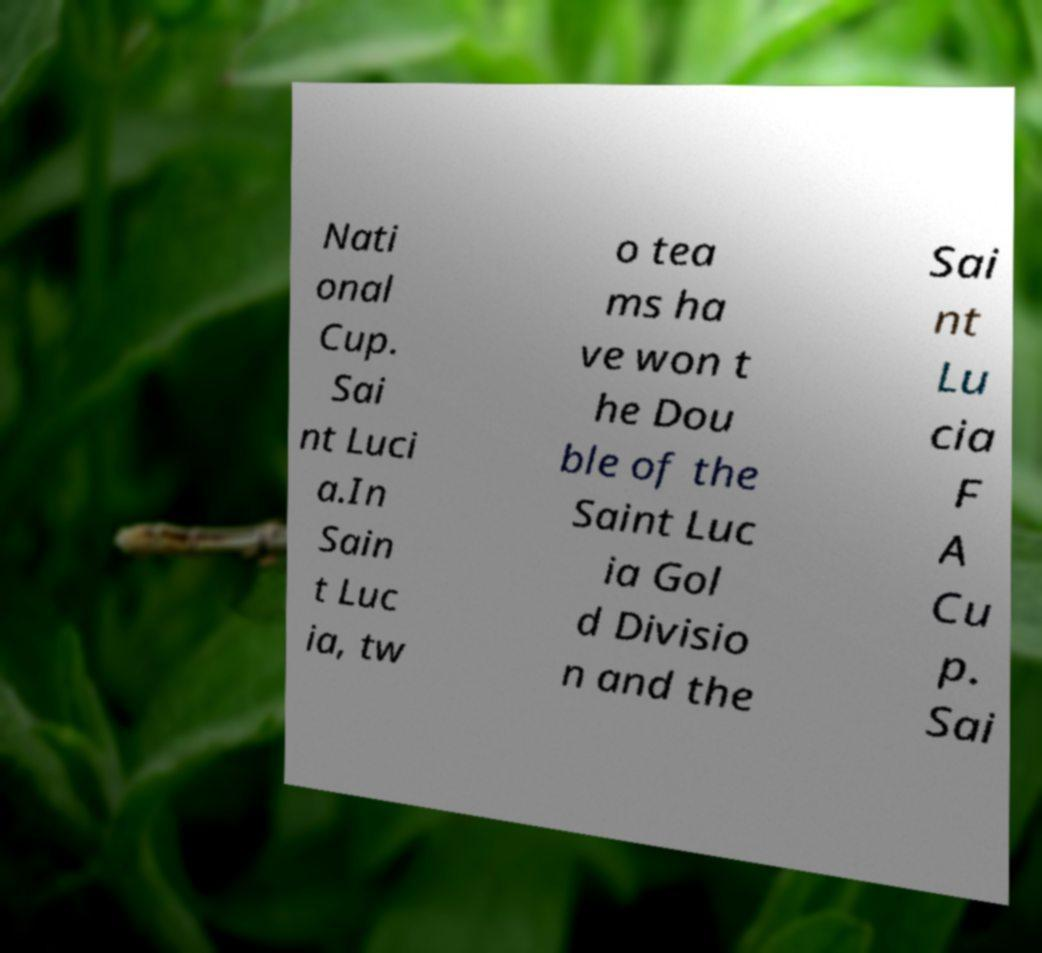For documentation purposes, I need the text within this image transcribed. Could you provide that? Nati onal Cup. Sai nt Luci a.In Sain t Luc ia, tw o tea ms ha ve won t he Dou ble of the Saint Luc ia Gol d Divisio n and the Sai nt Lu cia F A Cu p. Sai 